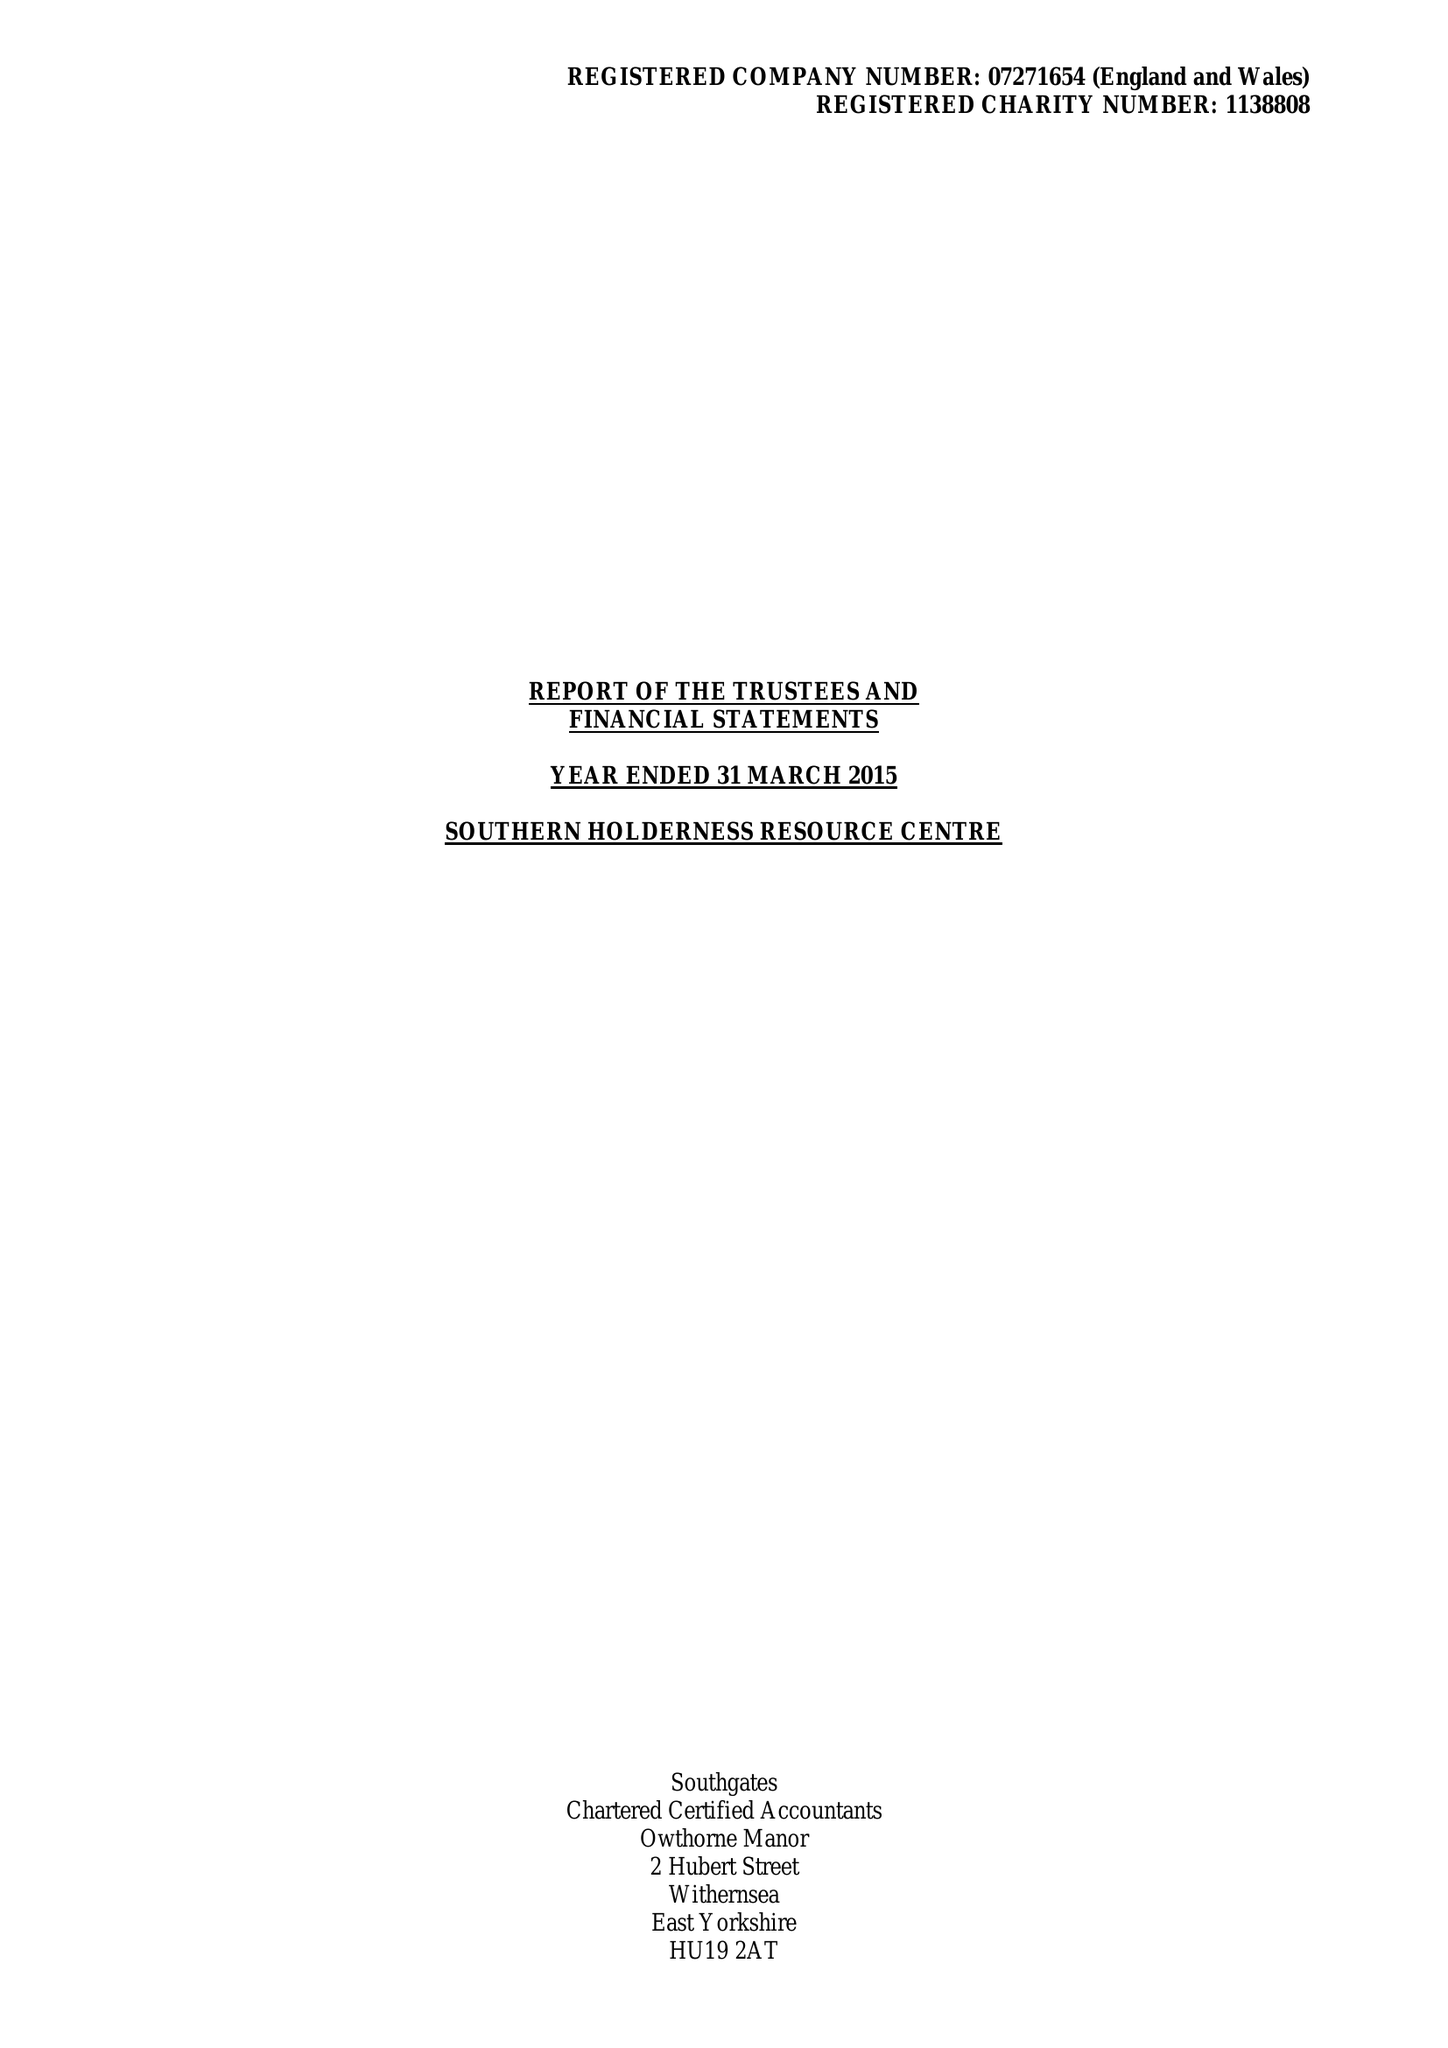What is the value for the income_annually_in_british_pounds?
Answer the question using a single word or phrase. 361876.00 